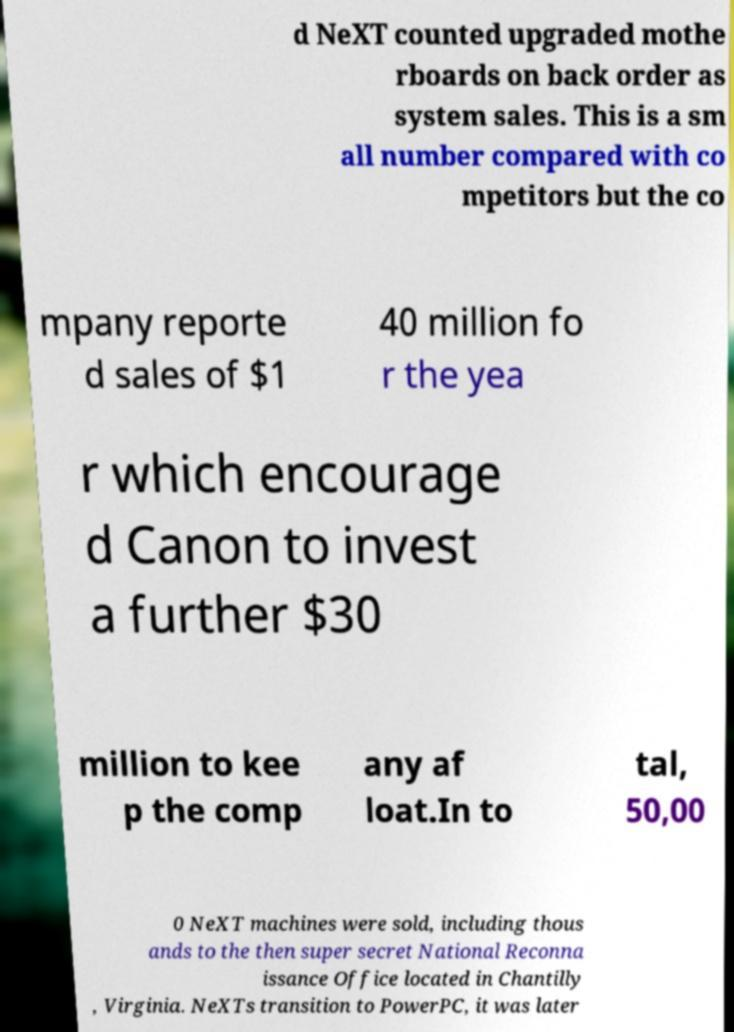Could you assist in decoding the text presented in this image and type it out clearly? d NeXT counted upgraded mothe rboards on back order as system sales. This is a sm all number compared with co mpetitors but the co mpany reporte d sales of $1 40 million fo r the yea r which encourage d Canon to invest a further $30 million to kee p the comp any af loat.In to tal, 50,00 0 NeXT machines were sold, including thous ands to the then super secret National Reconna issance Office located in Chantilly , Virginia. NeXTs transition to PowerPC, it was later 